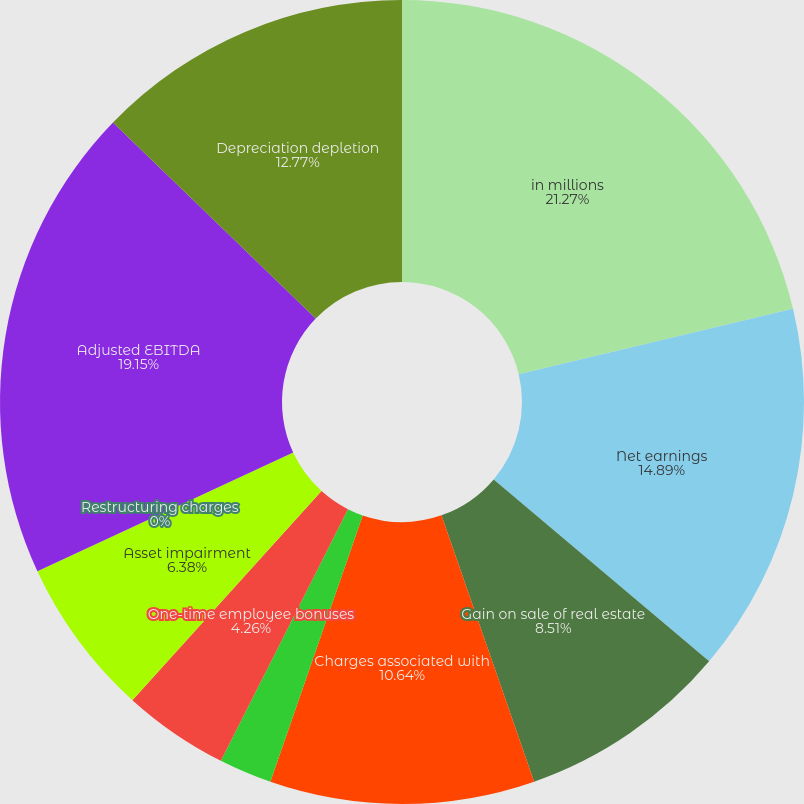<chart> <loc_0><loc_0><loc_500><loc_500><pie_chart><fcel>in millions<fcel>Net earnings<fcel>Gain on sale of real estate<fcel>Charges associated with<fcel>Business development net of<fcel>One-time employee bonuses<fcel>Asset impairment<fcel>Restructuring charges<fcel>Adjusted EBITDA<fcel>Depreciation depletion<nl><fcel>21.27%<fcel>14.89%<fcel>8.51%<fcel>10.64%<fcel>2.13%<fcel>4.26%<fcel>6.38%<fcel>0.0%<fcel>19.15%<fcel>12.77%<nl></chart> 